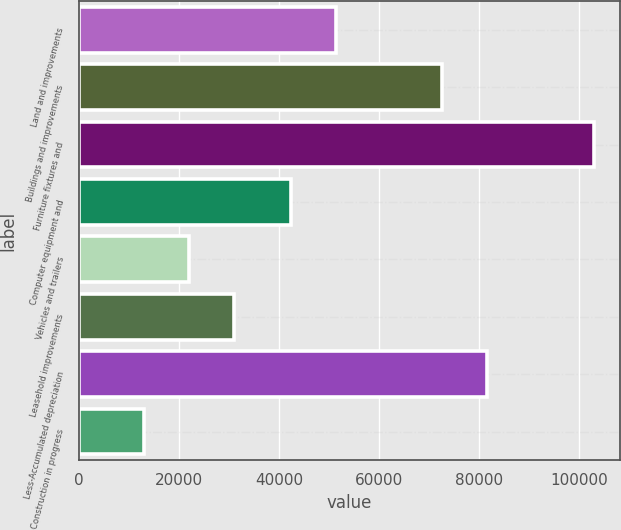<chart> <loc_0><loc_0><loc_500><loc_500><bar_chart><fcel>Land and improvements<fcel>Buildings and improvements<fcel>Furniture fixtures and<fcel>Computer equipment and<fcel>Vehicles and trailers<fcel>Leasehold improvements<fcel>Less-Accumulated depreciation<fcel>Construction in progress<nl><fcel>51486.8<fcel>72665<fcel>103017<fcel>42482<fcel>21973.8<fcel>30978.6<fcel>81669.8<fcel>12969<nl></chart> 